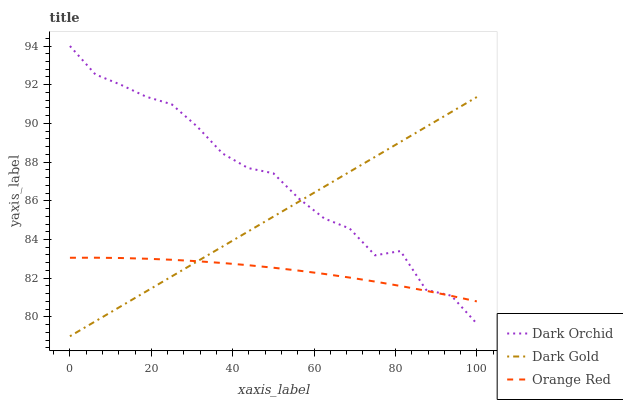Does Dark Gold have the minimum area under the curve?
Answer yes or no. No. Does Dark Gold have the maximum area under the curve?
Answer yes or no. No. Is Dark Orchid the smoothest?
Answer yes or no. No. Is Dark Gold the roughest?
Answer yes or no. No. Does Dark Orchid have the lowest value?
Answer yes or no. No. Does Dark Gold have the highest value?
Answer yes or no. No. 